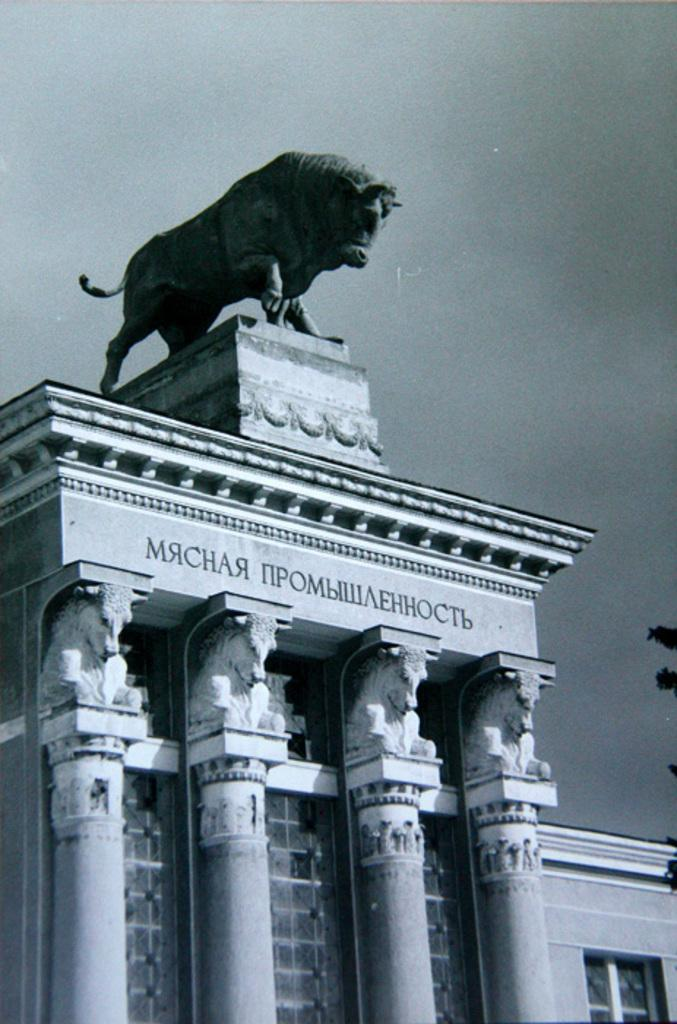What type of structure is depicted in the image? There is a building in the image. What is located above the building? There is a statue above the building. What architectural features can be seen on the building? The building has pillars. Are there any openings in the building? Yes, the building has windows. What can be seen in the background of the image? The sky is visible in the background of the image. What channel is the building tuned to in the image? The image does not depict a television or any indication of a channel being watched, so this question cannot be answered. 